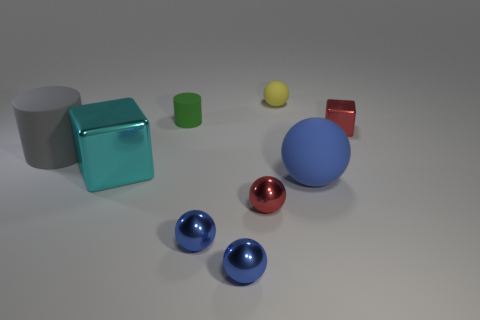There is a shiny block on the left side of the metal cube right of the small rubber cylinder; what color is it? The shiny block situated to the left side of the metal cube, which is itself located to the right of the small rubber cylinder, is cyan in color, exhibiting a lustrous surface that reflects the light source in the scene. 